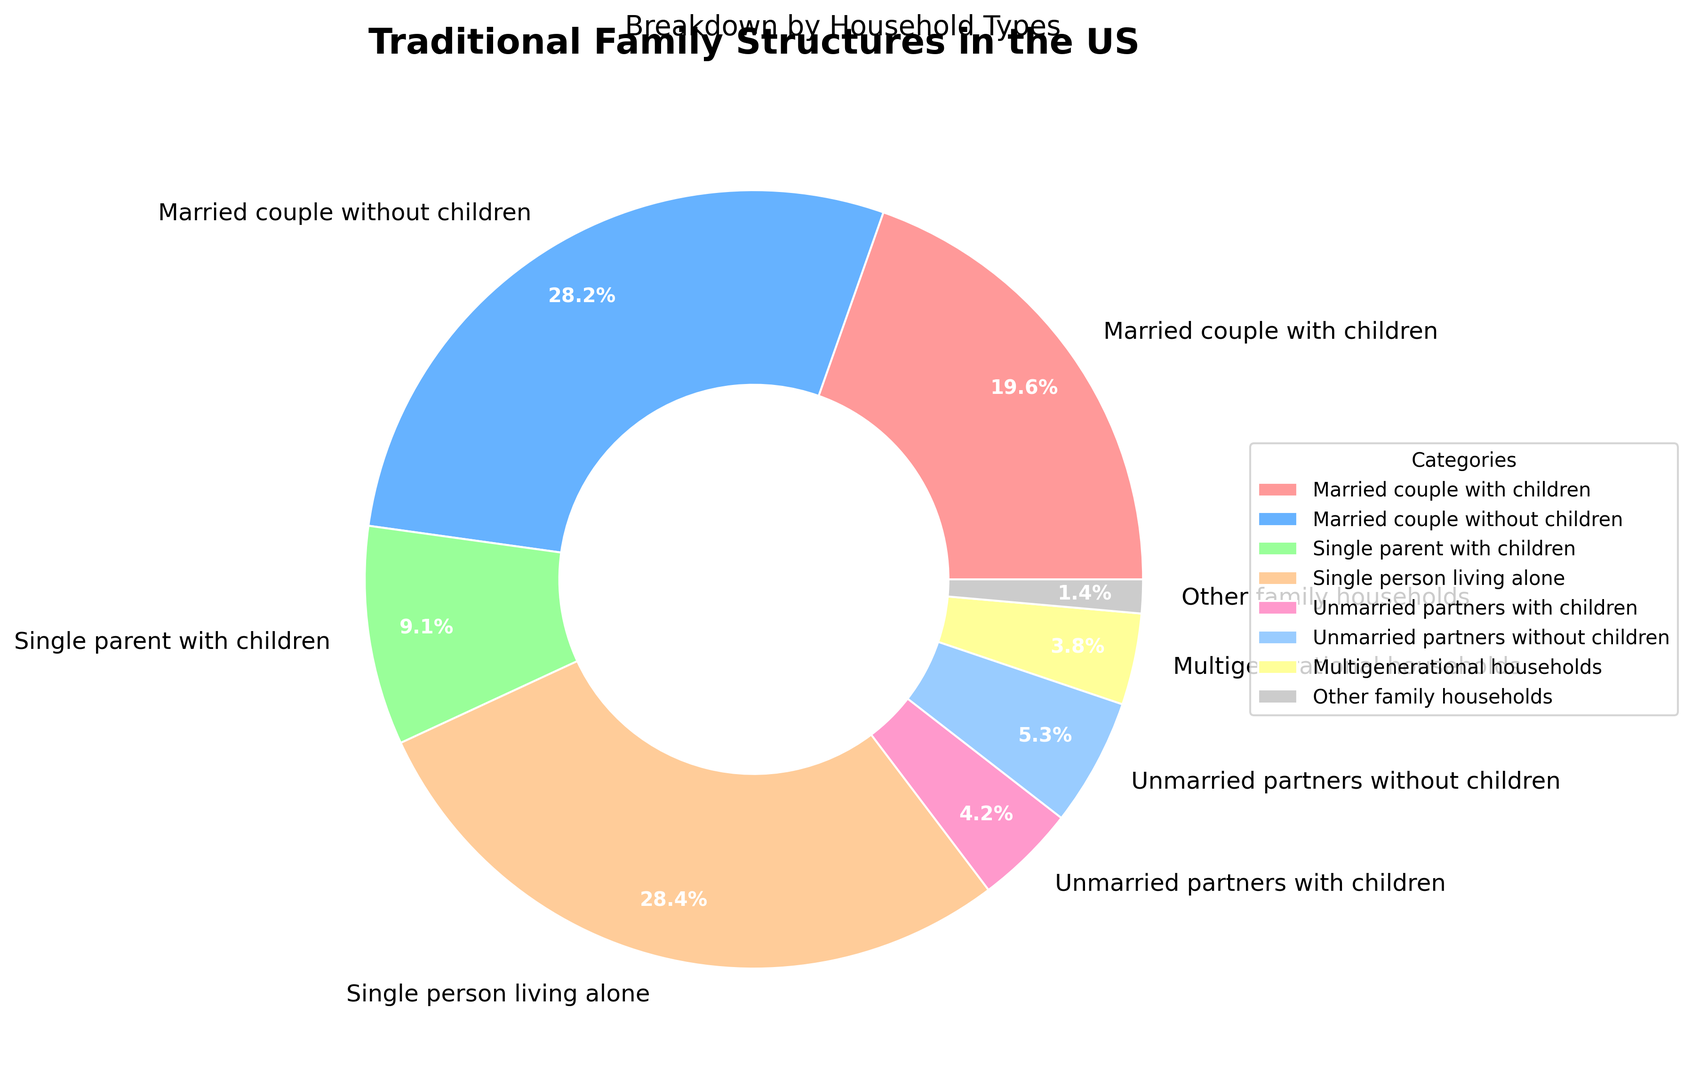Which household type has the highest percentage? The pie chart shows different household types with their respective percentages. By visually comparing the segments, the "Single person living alone" household type has the highest percentage at 28.4%.
Answer: Single person living alone Which household type has the lowest percentage? By visually comparing the segments, we can see that the "Other family households" type has the smallest segment, representing 1.4%.
Answer: Other family households What's the combined percentage of "Married couple with children" and "Married couple without children"? To get the combined percentage, we add the percentage of "Married couple with children" (19.6%) and "Married couple without children" (28.2%). The combined total is 19.6% + 28.2% = 47.8%.
Answer: 47.8% How many household types have a percentage greater than 20%? By examining the pie chart segments, the household types with percentages greater than 20% are "Married couple without children" (28.2%) and "Single person living alone" (28.4%). This makes a total of 2 household types.
Answer: 2 Which category does the red section in the pie chart represent? The red section in the pie chart visually represents the "Single person living alone" category, which has the highest percentage (28.4%).
Answer: Single person living alone Is the percentage of "Single parent with children" more or less than that of "Unmarried partners with children" and "Multigenerational households" combined? Adding the percentages of "Unmarried partners with children" (4.2%) and "Multigenerational households" (3.8%) gives 4.2% + 3.8% = 8.0%. Since the percentage of "Single parent with children" is 9.1%, it is more.
Answer: More Which household types together form nearly half of the traditional family structures? From the pie chart, we can see that "Married couple without children" (28.2%) and "Single person living alone" (28.4%) together sum up to 28.2% + 28.4% = 56.6%, which is more than half. Another pair is "Married couple with children" (19.6%) and "Married couple without children" (28.2%) which together make 19.6% + 28.2% = 47.8%, which is nearly half.
Answer: Married couple without children, Single person living alone Which occupied segment appears to be the second-largest in the pie chart? Visually analyzing the pie chart, the second-largest segment is for the "Married couple without children" category, which has a percentage of 28.2%.
Answer: Married couple without children What is the total percentage of households where children are involved? Sum the percentages of "Married couple with children" (19.6%), "Single parent with children" (9.1%), and "Unmarried partners with children" (4.2%). The total is 19.6% + 9.1% + 4.2% = 32.9%.
Answer: 32.9% 